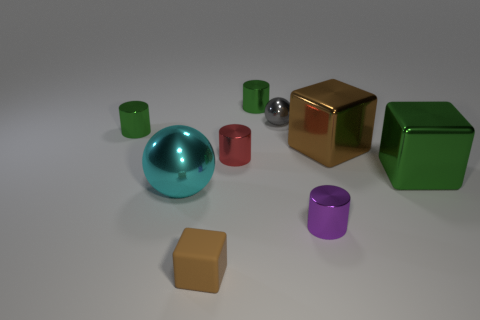What shape is the thing that is the same color as the tiny block?
Keep it short and to the point. Cube. Is the number of purple metal things in front of the tiny purple cylinder less than the number of brown rubber blocks?
Offer a terse response. Yes. What number of other things are there of the same size as the cyan metallic ball?
Provide a short and direct response. 2. Is the shape of the green thing that is on the left side of the small red metallic object the same as  the red metal object?
Offer a terse response. Yes. Is the number of tiny red metal cylinders right of the big green metal object greater than the number of small red metal things?
Provide a succinct answer. No. There is a thing that is behind the green metal block and on the right side of the small purple object; what material is it?
Provide a succinct answer. Metal. What number of small objects are right of the large cyan ball and behind the small red metallic cylinder?
Offer a terse response. 2. What is the material of the gray sphere?
Offer a very short reply. Metal. Is the number of brown rubber cubes behind the red metal thing the same as the number of large gray metal blocks?
Offer a very short reply. Yes. What number of other small brown things have the same shape as the small brown matte object?
Your answer should be very brief. 0. 